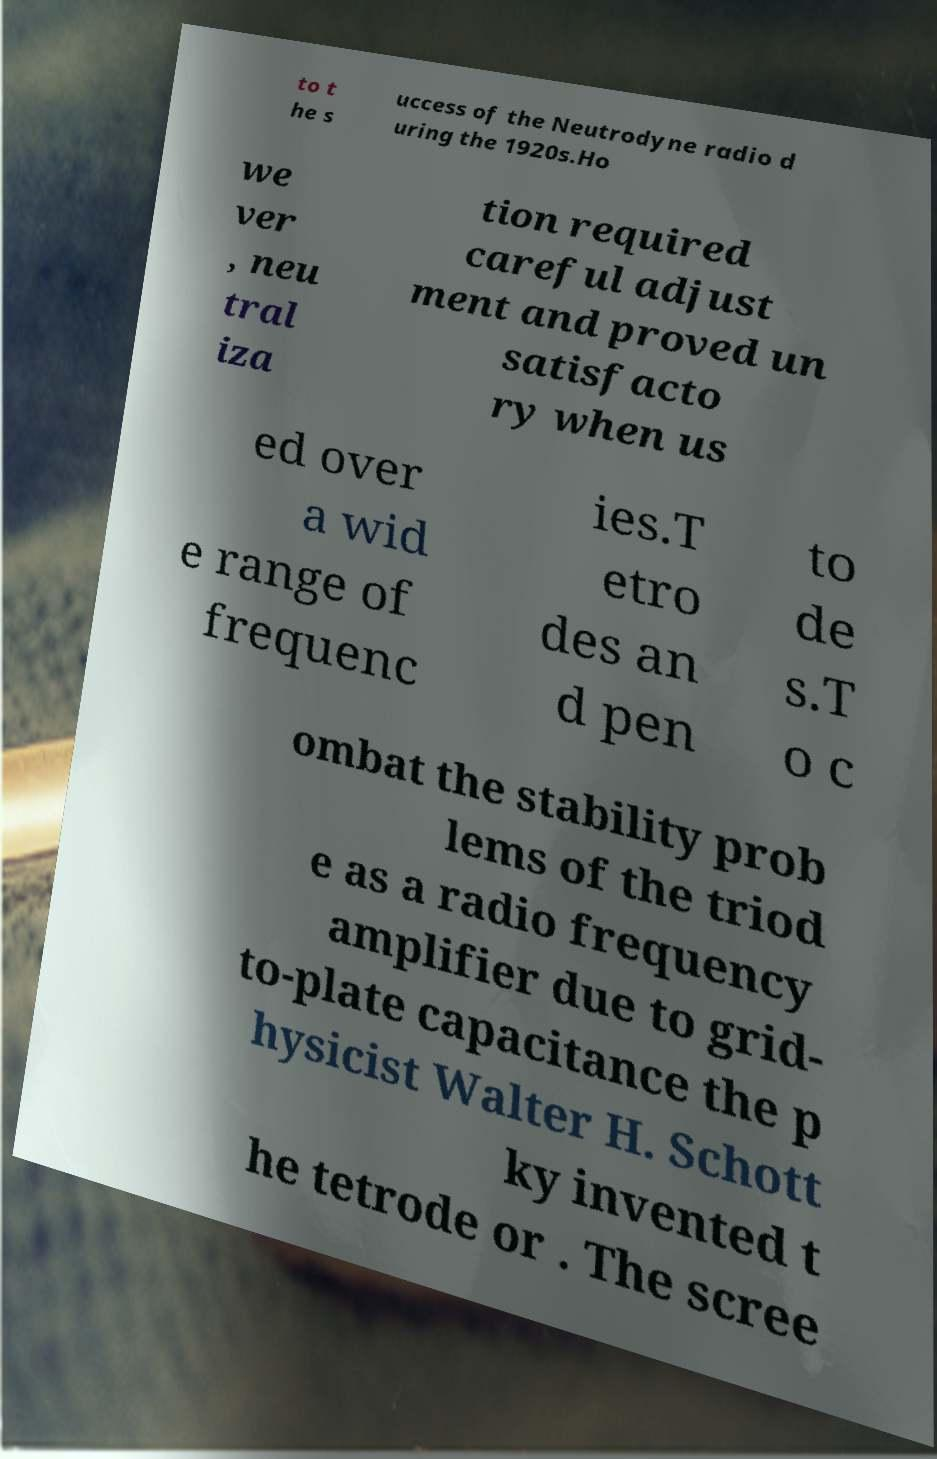For documentation purposes, I need the text within this image transcribed. Could you provide that? to t he s uccess of the Neutrodyne radio d uring the 1920s.Ho we ver , neu tral iza tion required careful adjust ment and proved un satisfacto ry when us ed over a wid e range of frequenc ies.T etro des an d pen to de s.T o c ombat the stability prob lems of the triod e as a radio frequency amplifier due to grid- to-plate capacitance the p hysicist Walter H. Schott ky invented t he tetrode or . The scree 